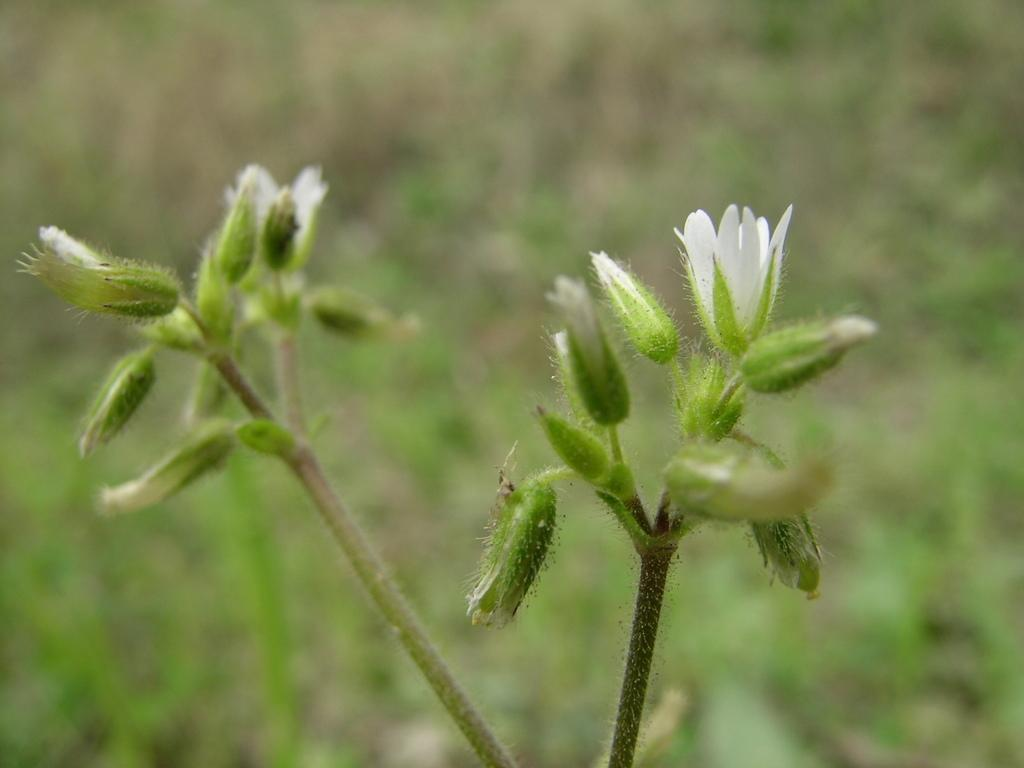What type of plant is visible in the image? There are stems with flowers in the image. Can you describe the background of the image? The background of the image is blurry. What is the opinion of the goose in the image? There is no goose present in the image, so it is not possible to determine its opinion. 